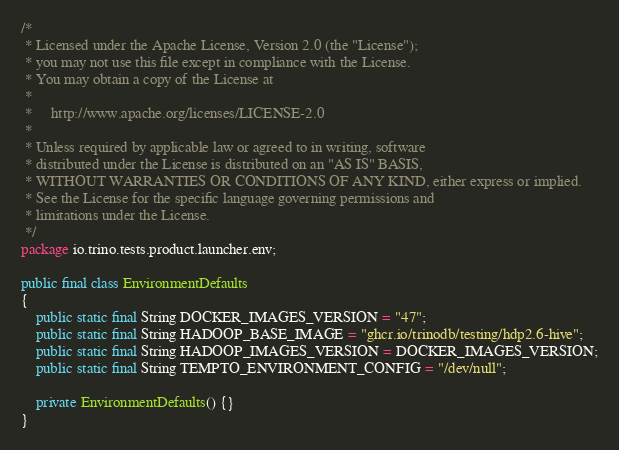<code> <loc_0><loc_0><loc_500><loc_500><_Java_>/*
 * Licensed under the Apache License, Version 2.0 (the "License");
 * you may not use this file except in compliance with the License.
 * You may obtain a copy of the License at
 *
 *     http://www.apache.org/licenses/LICENSE-2.0
 *
 * Unless required by applicable law or agreed to in writing, software
 * distributed under the License is distributed on an "AS IS" BASIS,
 * WITHOUT WARRANTIES OR CONDITIONS OF ANY KIND, either express or implied.
 * See the License for the specific language governing permissions and
 * limitations under the License.
 */
package io.trino.tests.product.launcher.env;

public final class EnvironmentDefaults
{
    public static final String DOCKER_IMAGES_VERSION = "47";
    public static final String HADOOP_BASE_IMAGE = "ghcr.io/trinodb/testing/hdp2.6-hive";
    public static final String HADOOP_IMAGES_VERSION = DOCKER_IMAGES_VERSION;
    public static final String TEMPTO_ENVIRONMENT_CONFIG = "/dev/null";

    private EnvironmentDefaults() {}
}
</code> 